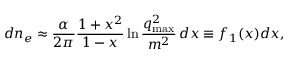<formula> <loc_0><loc_0><loc_500><loc_500>d n _ { e } \approx \frac { \alpha } { 2 \pi } \frac { 1 + x ^ { 2 } } { 1 - x } \ln { \frac { q _ { \max } ^ { 2 } } { m ^ { 2 } } } \, d x \equiv f _ { 1 } ( x ) d x ,</formula> 